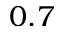<formula> <loc_0><loc_0><loc_500><loc_500>0 . 7</formula> 